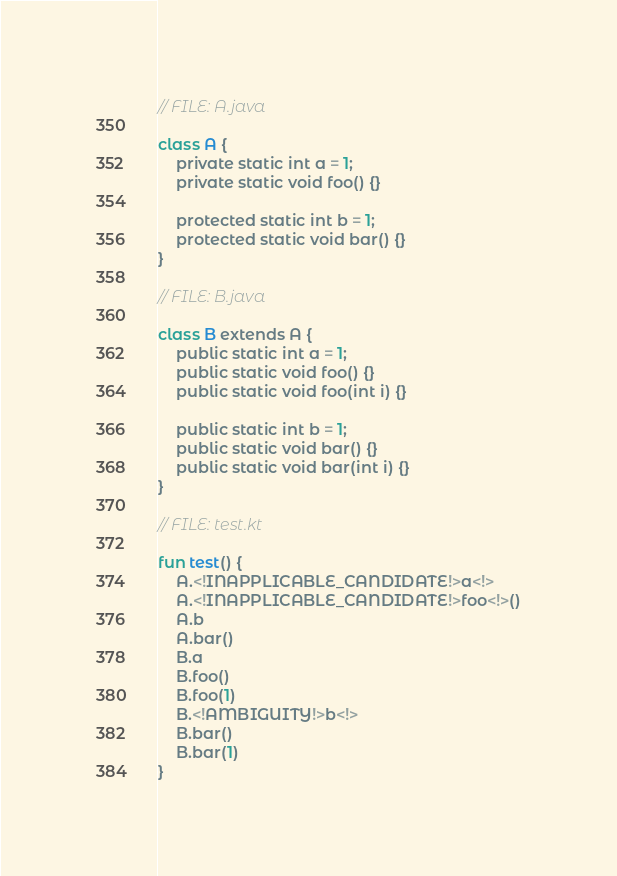<code> <loc_0><loc_0><loc_500><loc_500><_Kotlin_>// FILE: A.java

class A {
    private static int a = 1;
    private static void foo() {}

    protected static int b = 1;
    protected static void bar() {}
}

// FILE: B.java

class B extends A {
    public static int a = 1;
    public static void foo() {}
    public static void foo(int i) {}

    public static int b = 1;
    public static void bar() {}
    public static void bar(int i) {}
}

// FILE: test.kt

fun test() {
    A.<!INAPPLICABLE_CANDIDATE!>a<!>
    A.<!INAPPLICABLE_CANDIDATE!>foo<!>()
    A.b
    A.bar()
    B.a
    B.foo()
    B.foo(1)
    B.<!AMBIGUITY!>b<!>
    B.bar()
    B.bar(1)
}
</code> 